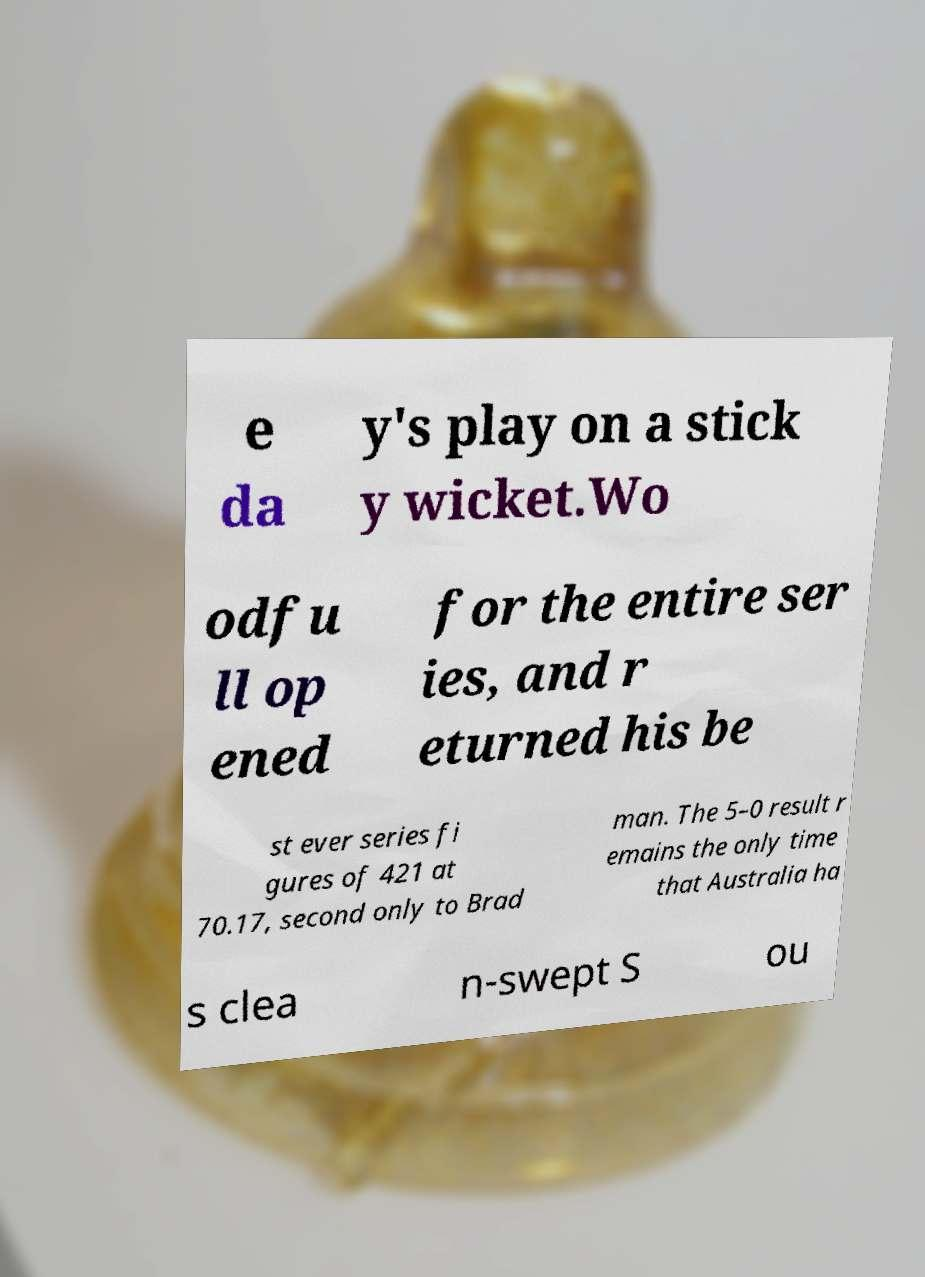What messages or text are displayed in this image? I need them in a readable, typed format. e da y's play on a stick y wicket.Wo odfu ll op ened for the entire ser ies, and r eturned his be st ever series fi gures of 421 at 70.17, second only to Brad man. The 5–0 result r emains the only time that Australia ha s clea n-swept S ou 